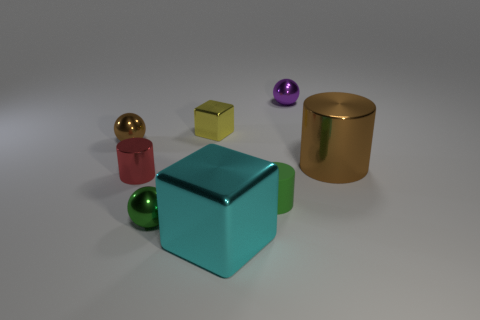Subtract all purple metallic spheres. How many spheres are left? 2 Add 1 small metallic cylinders. How many objects exist? 9 Subtract all blocks. How many objects are left? 6 Add 5 tiny yellow objects. How many tiny yellow objects exist? 6 Subtract all green spheres. How many spheres are left? 2 Subtract 0 yellow spheres. How many objects are left? 8 Subtract 1 cylinders. How many cylinders are left? 2 Subtract all yellow blocks. Subtract all cyan spheres. How many blocks are left? 1 Subtract all purple blocks. How many brown cylinders are left? 1 Subtract all small metal spheres. Subtract all red metal objects. How many objects are left? 4 